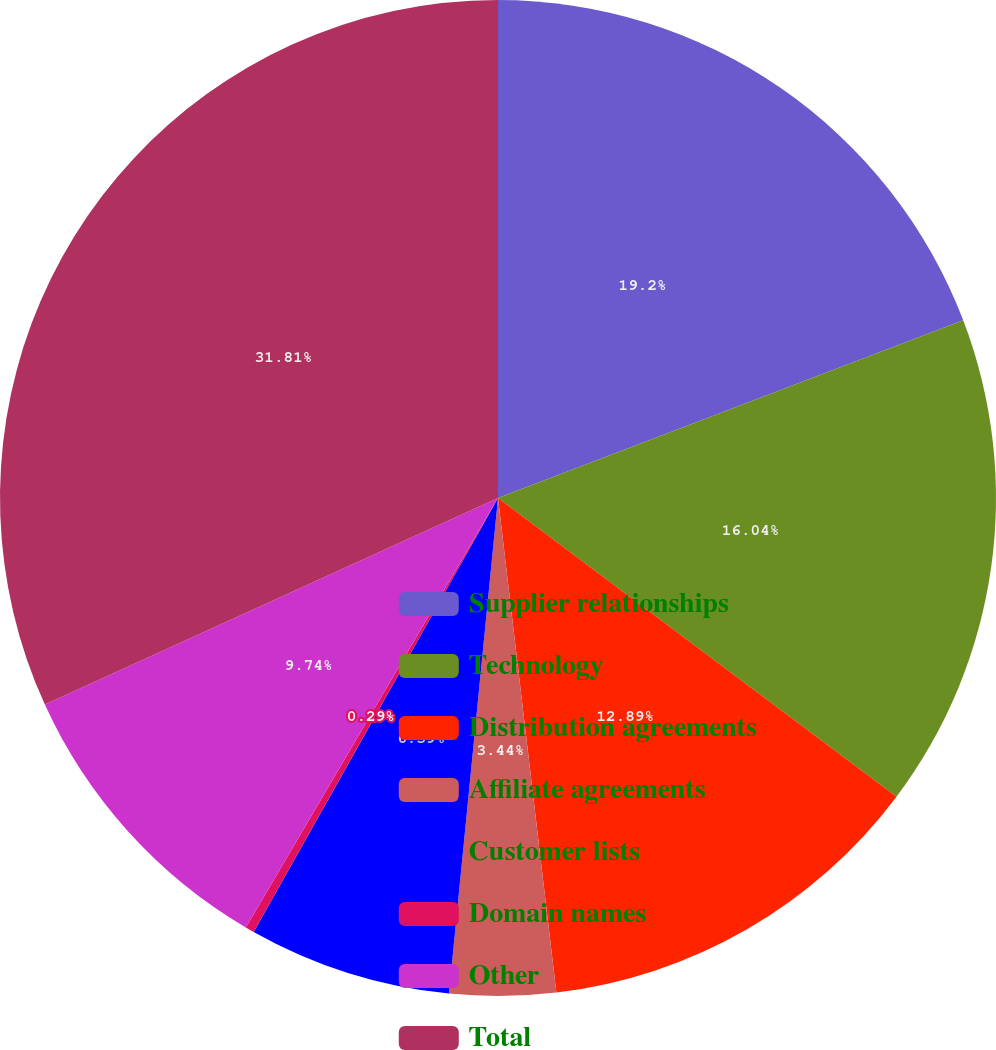Convert chart to OTSL. <chart><loc_0><loc_0><loc_500><loc_500><pie_chart><fcel>Supplier relationships<fcel>Technology<fcel>Distribution agreements<fcel>Affiliate agreements<fcel>Customer lists<fcel>Domain names<fcel>Other<fcel>Total<nl><fcel>19.19%<fcel>16.04%<fcel>12.89%<fcel>3.44%<fcel>6.59%<fcel>0.29%<fcel>9.74%<fcel>31.8%<nl></chart> 